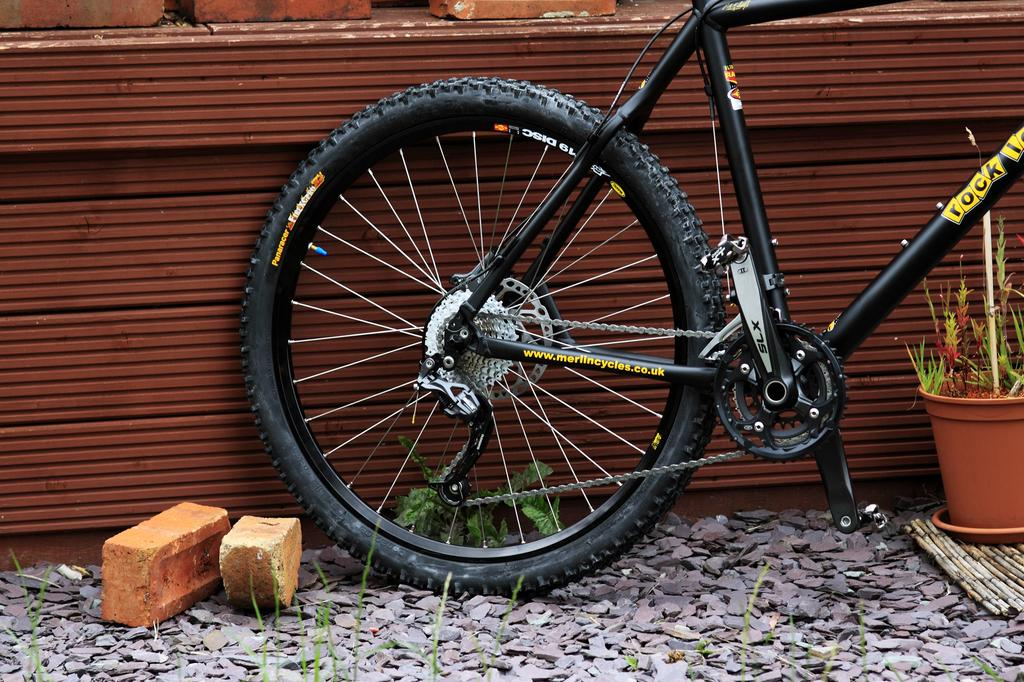What type of materials can be seen in the image? There are bricks and rocks in the image. What else is present in the image besides the materials? There are plants and a wall in the image. What object related to transportation can be seen in the image? There is a bicycle in the image. What type of shop can be seen in the image? There is no shop present in the image. Can you see a snail crawling on the bricks in the image? There is no snail visible in the image. 